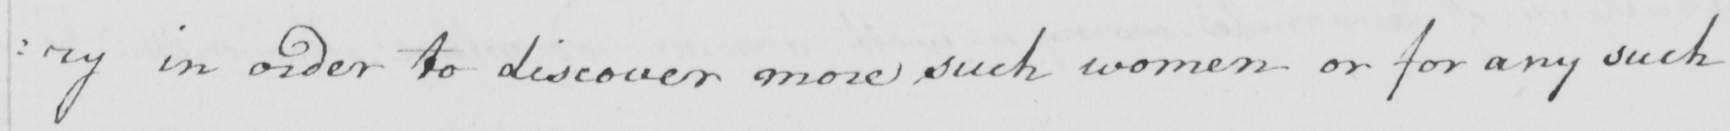Transcribe the text shown in this historical manuscript line. : ry in order to discover more such women or for any such 